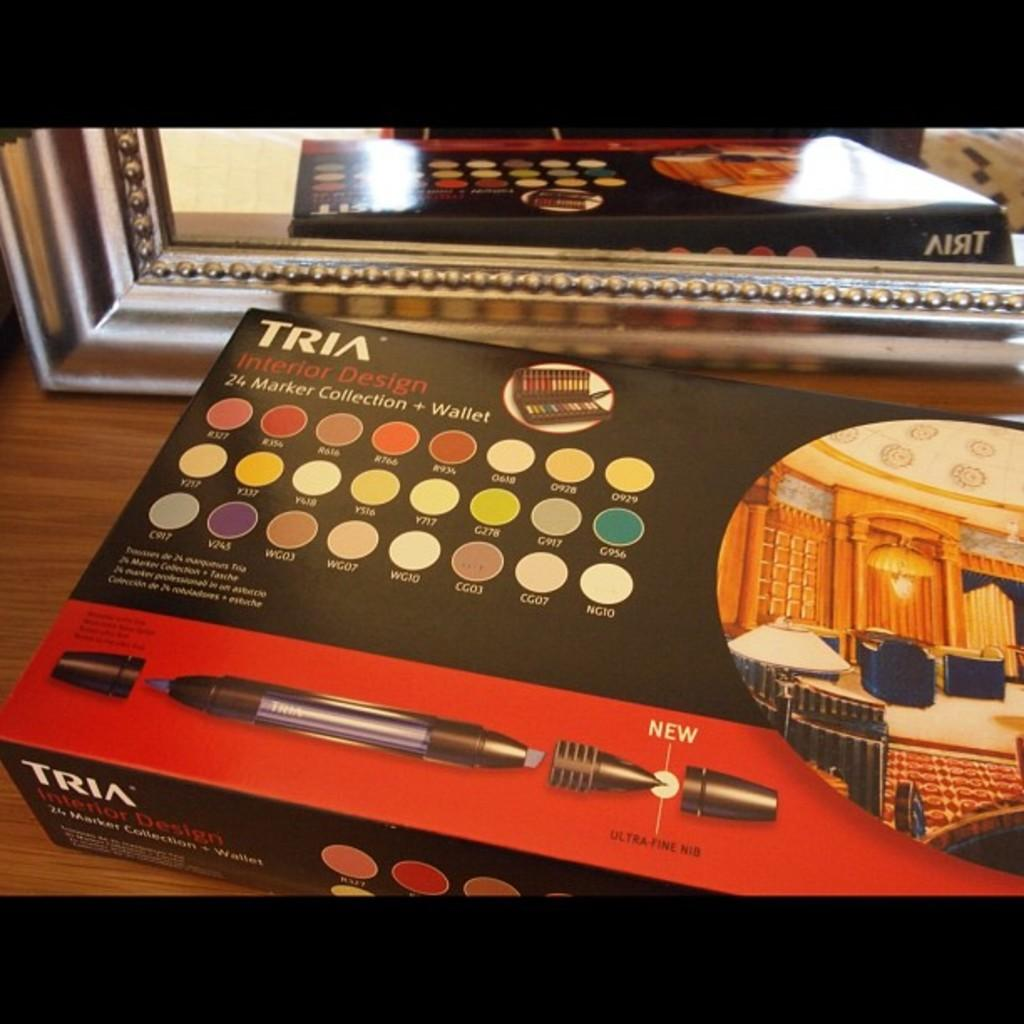<image>
Write a terse but informative summary of the picture. A box of Interior Design markers are on a wooden shelf with a mirror on it. 